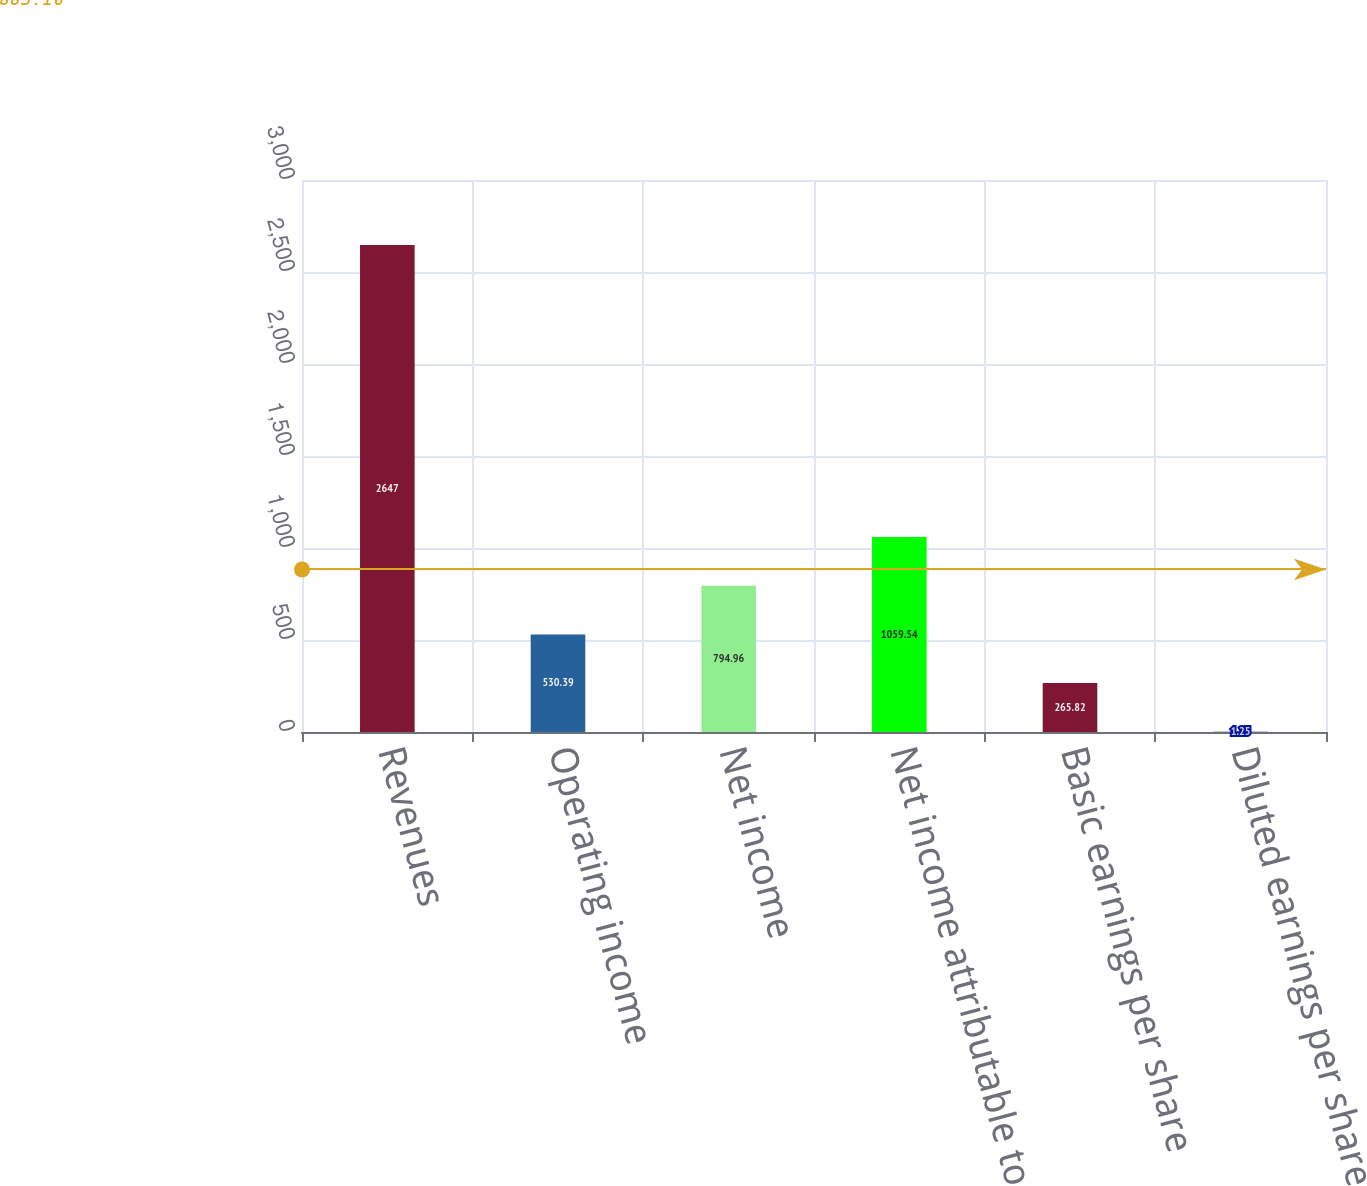Convert chart. <chart><loc_0><loc_0><loc_500><loc_500><bar_chart><fcel>Revenues<fcel>Operating income<fcel>Net income<fcel>Net income attributable to<fcel>Basic earnings per share<fcel>Diluted earnings per share<nl><fcel>2647<fcel>530.39<fcel>794.96<fcel>1059.54<fcel>265.82<fcel>1.25<nl></chart> 